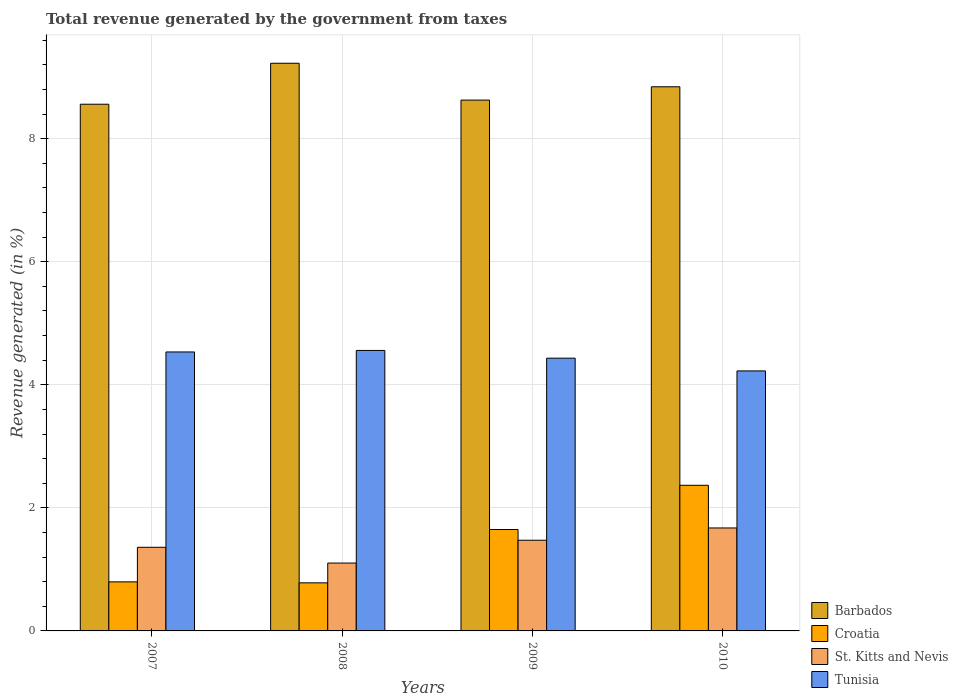How many different coloured bars are there?
Your response must be concise. 4. Are the number of bars per tick equal to the number of legend labels?
Keep it short and to the point. Yes. Are the number of bars on each tick of the X-axis equal?
Your answer should be very brief. Yes. How many bars are there on the 2nd tick from the left?
Offer a terse response. 4. What is the label of the 3rd group of bars from the left?
Offer a very short reply. 2009. In how many cases, is the number of bars for a given year not equal to the number of legend labels?
Offer a very short reply. 0. What is the total revenue generated in St. Kitts and Nevis in 2010?
Provide a short and direct response. 1.67. Across all years, what is the maximum total revenue generated in Croatia?
Your answer should be very brief. 2.37. Across all years, what is the minimum total revenue generated in Tunisia?
Offer a very short reply. 4.23. In which year was the total revenue generated in Barbados maximum?
Provide a short and direct response. 2008. In which year was the total revenue generated in St. Kitts and Nevis minimum?
Give a very brief answer. 2008. What is the total total revenue generated in Tunisia in the graph?
Offer a terse response. 17.75. What is the difference between the total revenue generated in Tunisia in 2007 and that in 2009?
Your answer should be compact. 0.1. What is the difference between the total revenue generated in Tunisia in 2007 and the total revenue generated in Barbados in 2010?
Offer a very short reply. -4.31. What is the average total revenue generated in St. Kitts and Nevis per year?
Offer a very short reply. 1.4. In the year 2009, what is the difference between the total revenue generated in Croatia and total revenue generated in Barbados?
Your answer should be very brief. -6.98. What is the ratio of the total revenue generated in Barbados in 2008 to that in 2010?
Your response must be concise. 1.04. Is the total revenue generated in St. Kitts and Nevis in 2007 less than that in 2010?
Provide a succinct answer. Yes. Is the difference between the total revenue generated in Croatia in 2007 and 2009 greater than the difference between the total revenue generated in Barbados in 2007 and 2009?
Your response must be concise. No. What is the difference between the highest and the second highest total revenue generated in Tunisia?
Your response must be concise. 0.02. What is the difference between the highest and the lowest total revenue generated in Tunisia?
Your answer should be compact. 0.33. In how many years, is the total revenue generated in Tunisia greater than the average total revenue generated in Tunisia taken over all years?
Offer a very short reply. 2. Is the sum of the total revenue generated in St. Kitts and Nevis in 2007 and 2008 greater than the maximum total revenue generated in Tunisia across all years?
Ensure brevity in your answer.  No. Is it the case that in every year, the sum of the total revenue generated in Croatia and total revenue generated in Barbados is greater than the sum of total revenue generated in Tunisia and total revenue generated in St. Kitts and Nevis?
Make the answer very short. No. What does the 3rd bar from the left in 2008 represents?
Keep it short and to the point. St. Kitts and Nevis. What does the 4th bar from the right in 2008 represents?
Keep it short and to the point. Barbados. Are all the bars in the graph horizontal?
Your answer should be compact. No. How many years are there in the graph?
Provide a succinct answer. 4. Does the graph contain any zero values?
Offer a terse response. No. Does the graph contain grids?
Your answer should be compact. Yes. How are the legend labels stacked?
Offer a terse response. Vertical. What is the title of the graph?
Provide a succinct answer. Total revenue generated by the government from taxes. What is the label or title of the Y-axis?
Keep it short and to the point. Revenue generated (in %). What is the Revenue generated (in %) of Barbados in 2007?
Offer a very short reply. 8.56. What is the Revenue generated (in %) in Croatia in 2007?
Ensure brevity in your answer.  0.8. What is the Revenue generated (in %) of St. Kitts and Nevis in 2007?
Keep it short and to the point. 1.36. What is the Revenue generated (in %) in Tunisia in 2007?
Your response must be concise. 4.53. What is the Revenue generated (in %) in Barbados in 2008?
Your answer should be compact. 9.23. What is the Revenue generated (in %) of Croatia in 2008?
Keep it short and to the point. 0.78. What is the Revenue generated (in %) of St. Kitts and Nevis in 2008?
Give a very brief answer. 1.1. What is the Revenue generated (in %) in Tunisia in 2008?
Make the answer very short. 4.56. What is the Revenue generated (in %) in Barbados in 2009?
Provide a short and direct response. 8.63. What is the Revenue generated (in %) of Croatia in 2009?
Make the answer very short. 1.65. What is the Revenue generated (in %) of St. Kitts and Nevis in 2009?
Make the answer very short. 1.47. What is the Revenue generated (in %) of Tunisia in 2009?
Give a very brief answer. 4.43. What is the Revenue generated (in %) of Barbados in 2010?
Provide a succinct answer. 8.84. What is the Revenue generated (in %) in Croatia in 2010?
Give a very brief answer. 2.37. What is the Revenue generated (in %) in St. Kitts and Nevis in 2010?
Keep it short and to the point. 1.67. What is the Revenue generated (in %) in Tunisia in 2010?
Offer a very short reply. 4.23. Across all years, what is the maximum Revenue generated (in %) in Barbados?
Make the answer very short. 9.23. Across all years, what is the maximum Revenue generated (in %) of Croatia?
Keep it short and to the point. 2.37. Across all years, what is the maximum Revenue generated (in %) of St. Kitts and Nevis?
Provide a succinct answer. 1.67. Across all years, what is the maximum Revenue generated (in %) of Tunisia?
Offer a very short reply. 4.56. Across all years, what is the minimum Revenue generated (in %) of Barbados?
Give a very brief answer. 8.56. Across all years, what is the minimum Revenue generated (in %) of Croatia?
Give a very brief answer. 0.78. Across all years, what is the minimum Revenue generated (in %) of St. Kitts and Nevis?
Make the answer very short. 1.1. Across all years, what is the minimum Revenue generated (in %) of Tunisia?
Offer a very short reply. 4.23. What is the total Revenue generated (in %) in Barbados in the graph?
Make the answer very short. 35.25. What is the total Revenue generated (in %) of Croatia in the graph?
Offer a very short reply. 5.59. What is the total Revenue generated (in %) of St. Kitts and Nevis in the graph?
Ensure brevity in your answer.  5.61. What is the total Revenue generated (in %) in Tunisia in the graph?
Your answer should be very brief. 17.75. What is the difference between the Revenue generated (in %) in Barbados in 2007 and that in 2008?
Provide a short and direct response. -0.67. What is the difference between the Revenue generated (in %) of Croatia in 2007 and that in 2008?
Ensure brevity in your answer.  0.02. What is the difference between the Revenue generated (in %) in St. Kitts and Nevis in 2007 and that in 2008?
Provide a short and direct response. 0.26. What is the difference between the Revenue generated (in %) in Tunisia in 2007 and that in 2008?
Your answer should be compact. -0.02. What is the difference between the Revenue generated (in %) in Barbados in 2007 and that in 2009?
Provide a succinct answer. -0.07. What is the difference between the Revenue generated (in %) of Croatia in 2007 and that in 2009?
Offer a very short reply. -0.85. What is the difference between the Revenue generated (in %) in St. Kitts and Nevis in 2007 and that in 2009?
Make the answer very short. -0.11. What is the difference between the Revenue generated (in %) of Tunisia in 2007 and that in 2009?
Your response must be concise. 0.1. What is the difference between the Revenue generated (in %) in Barbados in 2007 and that in 2010?
Ensure brevity in your answer.  -0.28. What is the difference between the Revenue generated (in %) of Croatia in 2007 and that in 2010?
Your response must be concise. -1.57. What is the difference between the Revenue generated (in %) of St. Kitts and Nevis in 2007 and that in 2010?
Your answer should be very brief. -0.31. What is the difference between the Revenue generated (in %) of Tunisia in 2007 and that in 2010?
Make the answer very short. 0.31. What is the difference between the Revenue generated (in %) of Barbados in 2008 and that in 2009?
Your answer should be very brief. 0.6. What is the difference between the Revenue generated (in %) of Croatia in 2008 and that in 2009?
Offer a terse response. -0.87. What is the difference between the Revenue generated (in %) in St. Kitts and Nevis in 2008 and that in 2009?
Your answer should be compact. -0.37. What is the difference between the Revenue generated (in %) in Tunisia in 2008 and that in 2009?
Ensure brevity in your answer.  0.13. What is the difference between the Revenue generated (in %) in Barbados in 2008 and that in 2010?
Provide a succinct answer. 0.38. What is the difference between the Revenue generated (in %) in Croatia in 2008 and that in 2010?
Keep it short and to the point. -1.59. What is the difference between the Revenue generated (in %) of St. Kitts and Nevis in 2008 and that in 2010?
Your response must be concise. -0.57. What is the difference between the Revenue generated (in %) in Tunisia in 2008 and that in 2010?
Give a very brief answer. 0.33. What is the difference between the Revenue generated (in %) of Barbados in 2009 and that in 2010?
Ensure brevity in your answer.  -0.22. What is the difference between the Revenue generated (in %) of Croatia in 2009 and that in 2010?
Your response must be concise. -0.72. What is the difference between the Revenue generated (in %) in St. Kitts and Nevis in 2009 and that in 2010?
Ensure brevity in your answer.  -0.2. What is the difference between the Revenue generated (in %) in Tunisia in 2009 and that in 2010?
Your answer should be compact. 0.21. What is the difference between the Revenue generated (in %) in Barbados in 2007 and the Revenue generated (in %) in Croatia in 2008?
Your answer should be compact. 7.78. What is the difference between the Revenue generated (in %) in Barbados in 2007 and the Revenue generated (in %) in St. Kitts and Nevis in 2008?
Your response must be concise. 7.46. What is the difference between the Revenue generated (in %) of Barbados in 2007 and the Revenue generated (in %) of Tunisia in 2008?
Ensure brevity in your answer.  4. What is the difference between the Revenue generated (in %) of Croatia in 2007 and the Revenue generated (in %) of St. Kitts and Nevis in 2008?
Give a very brief answer. -0.31. What is the difference between the Revenue generated (in %) of Croatia in 2007 and the Revenue generated (in %) of Tunisia in 2008?
Keep it short and to the point. -3.76. What is the difference between the Revenue generated (in %) in St. Kitts and Nevis in 2007 and the Revenue generated (in %) in Tunisia in 2008?
Ensure brevity in your answer.  -3.2. What is the difference between the Revenue generated (in %) of Barbados in 2007 and the Revenue generated (in %) of Croatia in 2009?
Your answer should be compact. 6.91. What is the difference between the Revenue generated (in %) of Barbados in 2007 and the Revenue generated (in %) of St. Kitts and Nevis in 2009?
Ensure brevity in your answer.  7.09. What is the difference between the Revenue generated (in %) of Barbados in 2007 and the Revenue generated (in %) of Tunisia in 2009?
Ensure brevity in your answer.  4.13. What is the difference between the Revenue generated (in %) in Croatia in 2007 and the Revenue generated (in %) in St. Kitts and Nevis in 2009?
Provide a succinct answer. -0.68. What is the difference between the Revenue generated (in %) of Croatia in 2007 and the Revenue generated (in %) of Tunisia in 2009?
Give a very brief answer. -3.64. What is the difference between the Revenue generated (in %) in St. Kitts and Nevis in 2007 and the Revenue generated (in %) in Tunisia in 2009?
Offer a very short reply. -3.07. What is the difference between the Revenue generated (in %) of Barbados in 2007 and the Revenue generated (in %) of Croatia in 2010?
Provide a succinct answer. 6.19. What is the difference between the Revenue generated (in %) of Barbados in 2007 and the Revenue generated (in %) of St. Kitts and Nevis in 2010?
Your answer should be compact. 6.89. What is the difference between the Revenue generated (in %) in Barbados in 2007 and the Revenue generated (in %) in Tunisia in 2010?
Your answer should be compact. 4.33. What is the difference between the Revenue generated (in %) in Croatia in 2007 and the Revenue generated (in %) in St. Kitts and Nevis in 2010?
Provide a short and direct response. -0.88. What is the difference between the Revenue generated (in %) of Croatia in 2007 and the Revenue generated (in %) of Tunisia in 2010?
Offer a very short reply. -3.43. What is the difference between the Revenue generated (in %) in St. Kitts and Nevis in 2007 and the Revenue generated (in %) in Tunisia in 2010?
Give a very brief answer. -2.87. What is the difference between the Revenue generated (in %) of Barbados in 2008 and the Revenue generated (in %) of Croatia in 2009?
Make the answer very short. 7.58. What is the difference between the Revenue generated (in %) in Barbados in 2008 and the Revenue generated (in %) in St. Kitts and Nevis in 2009?
Offer a very short reply. 7.75. What is the difference between the Revenue generated (in %) in Barbados in 2008 and the Revenue generated (in %) in Tunisia in 2009?
Provide a succinct answer. 4.79. What is the difference between the Revenue generated (in %) in Croatia in 2008 and the Revenue generated (in %) in St. Kitts and Nevis in 2009?
Your answer should be very brief. -0.69. What is the difference between the Revenue generated (in %) of Croatia in 2008 and the Revenue generated (in %) of Tunisia in 2009?
Offer a terse response. -3.65. What is the difference between the Revenue generated (in %) of St. Kitts and Nevis in 2008 and the Revenue generated (in %) of Tunisia in 2009?
Ensure brevity in your answer.  -3.33. What is the difference between the Revenue generated (in %) of Barbados in 2008 and the Revenue generated (in %) of Croatia in 2010?
Ensure brevity in your answer.  6.86. What is the difference between the Revenue generated (in %) of Barbados in 2008 and the Revenue generated (in %) of St. Kitts and Nevis in 2010?
Your response must be concise. 7.55. What is the difference between the Revenue generated (in %) of Barbados in 2008 and the Revenue generated (in %) of Tunisia in 2010?
Provide a short and direct response. 5. What is the difference between the Revenue generated (in %) of Croatia in 2008 and the Revenue generated (in %) of St. Kitts and Nevis in 2010?
Ensure brevity in your answer.  -0.89. What is the difference between the Revenue generated (in %) in Croatia in 2008 and the Revenue generated (in %) in Tunisia in 2010?
Provide a short and direct response. -3.44. What is the difference between the Revenue generated (in %) in St. Kitts and Nevis in 2008 and the Revenue generated (in %) in Tunisia in 2010?
Your response must be concise. -3.12. What is the difference between the Revenue generated (in %) in Barbados in 2009 and the Revenue generated (in %) in Croatia in 2010?
Offer a terse response. 6.26. What is the difference between the Revenue generated (in %) of Barbados in 2009 and the Revenue generated (in %) of St. Kitts and Nevis in 2010?
Give a very brief answer. 6.95. What is the difference between the Revenue generated (in %) in Barbados in 2009 and the Revenue generated (in %) in Tunisia in 2010?
Offer a terse response. 4.4. What is the difference between the Revenue generated (in %) in Croatia in 2009 and the Revenue generated (in %) in St. Kitts and Nevis in 2010?
Offer a terse response. -0.03. What is the difference between the Revenue generated (in %) in Croatia in 2009 and the Revenue generated (in %) in Tunisia in 2010?
Offer a terse response. -2.58. What is the difference between the Revenue generated (in %) of St. Kitts and Nevis in 2009 and the Revenue generated (in %) of Tunisia in 2010?
Offer a very short reply. -2.75. What is the average Revenue generated (in %) of Barbados per year?
Provide a short and direct response. 8.81. What is the average Revenue generated (in %) in Croatia per year?
Keep it short and to the point. 1.4. What is the average Revenue generated (in %) in St. Kitts and Nevis per year?
Your answer should be very brief. 1.4. What is the average Revenue generated (in %) of Tunisia per year?
Offer a very short reply. 4.44. In the year 2007, what is the difference between the Revenue generated (in %) in Barbados and Revenue generated (in %) in Croatia?
Your answer should be compact. 7.76. In the year 2007, what is the difference between the Revenue generated (in %) of Barbados and Revenue generated (in %) of St. Kitts and Nevis?
Your response must be concise. 7.2. In the year 2007, what is the difference between the Revenue generated (in %) in Barbados and Revenue generated (in %) in Tunisia?
Your answer should be very brief. 4.03. In the year 2007, what is the difference between the Revenue generated (in %) in Croatia and Revenue generated (in %) in St. Kitts and Nevis?
Offer a very short reply. -0.56. In the year 2007, what is the difference between the Revenue generated (in %) in Croatia and Revenue generated (in %) in Tunisia?
Keep it short and to the point. -3.74. In the year 2007, what is the difference between the Revenue generated (in %) in St. Kitts and Nevis and Revenue generated (in %) in Tunisia?
Keep it short and to the point. -3.17. In the year 2008, what is the difference between the Revenue generated (in %) in Barbados and Revenue generated (in %) in Croatia?
Offer a terse response. 8.44. In the year 2008, what is the difference between the Revenue generated (in %) of Barbados and Revenue generated (in %) of St. Kitts and Nevis?
Offer a terse response. 8.12. In the year 2008, what is the difference between the Revenue generated (in %) in Barbados and Revenue generated (in %) in Tunisia?
Ensure brevity in your answer.  4.67. In the year 2008, what is the difference between the Revenue generated (in %) in Croatia and Revenue generated (in %) in St. Kitts and Nevis?
Your answer should be compact. -0.32. In the year 2008, what is the difference between the Revenue generated (in %) of Croatia and Revenue generated (in %) of Tunisia?
Provide a succinct answer. -3.78. In the year 2008, what is the difference between the Revenue generated (in %) in St. Kitts and Nevis and Revenue generated (in %) in Tunisia?
Your response must be concise. -3.46. In the year 2009, what is the difference between the Revenue generated (in %) in Barbados and Revenue generated (in %) in Croatia?
Offer a very short reply. 6.98. In the year 2009, what is the difference between the Revenue generated (in %) of Barbados and Revenue generated (in %) of St. Kitts and Nevis?
Offer a terse response. 7.15. In the year 2009, what is the difference between the Revenue generated (in %) of Barbados and Revenue generated (in %) of Tunisia?
Offer a terse response. 4.19. In the year 2009, what is the difference between the Revenue generated (in %) in Croatia and Revenue generated (in %) in St. Kitts and Nevis?
Your response must be concise. 0.17. In the year 2009, what is the difference between the Revenue generated (in %) in Croatia and Revenue generated (in %) in Tunisia?
Make the answer very short. -2.78. In the year 2009, what is the difference between the Revenue generated (in %) in St. Kitts and Nevis and Revenue generated (in %) in Tunisia?
Give a very brief answer. -2.96. In the year 2010, what is the difference between the Revenue generated (in %) of Barbados and Revenue generated (in %) of Croatia?
Provide a short and direct response. 6.48. In the year 2010, what is the difference between the Revenue generated (in %) in Barbados and Revenue generated (in %) in St. Kitts and Nevis?
Ensure brevity in your answer.  7.17. In the year 2010, what is the difference between the Revenue generated (in %) of Barbados and Revenue generated (in %) of Tunisia?
Offer a terse response. 4.62. In the year 2010, what is the difference between the Revenue generated (in %) of Croatia and Revenue generated (in %) of St. Kitts and Nevis?
Provide a succinct answer. 0.69. In the year 2010, what is the difference between the Revenue generated (in %) of Croatia and Revenue generated (in %) of Tunisia?
Your response must be concise. -1.86. In the year 2010, what is the difference between the Revenue generated (in %) of St. Kitts and Nevis and Revenue generated (in %) of Tunisia?
Offer a very short reply. -2.55. What is the ratio of the Revenue generated (in %) in Barbados in 2007 to that in 2008?
Offer a very short reply. 0.93. What is the ratio of the Revenue generated (in %) in Croatia in 2007 to that in 2008?
Keep it short and to the point. 1.02. What is the ratio of the Revenue generated (in %) in St. Kitts and Nevis in 2007 to that in 2008?
Your response must be concise. 1.23. What is the ratio of the Revenue generated (in %) of Tunisia in 2007 to that in 2008?
Keep it short and to the point. 0.99. What is the ratio of the Revenue generated (in %) of Croatia in 2007 to that in 2009?
Keep it short and to the point. 0.48. What is the ratio of the Revenue generated (in %) in St. Kitts and Nevis in 2007 to that in 2009?
Offer a terse response. 0.92. What is the ratio of the Revenue generated (in %) of Tunisia in 2007 to that in 2009?
Your answer should be very brief. 1.02. What is the ratio of the Revenue generated (in %) in Barbados in 2007 to that in 2010?
Make the answer very short. 0.97. What is the ratio of the Revenue generated (in %) in Croatia in 2007 to that in 2010?
Your answer should be very brief. 0.34. What is the ratio of the Revenue generated (in %) of St. Kitts and Nevis in 2007 to that in 2010?
Your answer should be very brief. 0.81. What is the ratio of the Revenue generated (in %) of Tunisia in 2007 to that in 2010?
Give a very brief answer. 1.07. What is the ratio of the Revenue generated (in %) of Barbados in 2008 to that in 2009?
Your answer should be compact. 1.07. What is the ratio of the Revenue generated (in %) of Croatia in 2008 to that in 2009?
Your response must be concise. 0.47. What is the ratio of the Revenue generated (in %) in St. Kitts and Nevis in 2008 to that in 2009?
Keep it short and to the point. 0.75. What is the ratio of the Revenue generated (in %) in Tunisia in 2008 to that in 2009?
Your answer should be compact. 1.03. What is the ratio of the Revenue generated (in %) of Barbados in 2008 to that in 2010?
Your answer should be very brief. 1.04. What is the ratio of the Revenue generated (in %) in Croatia in 2008 to that in 2010?
Your answer should be compact. 0.33. What is the ratio of the Revenue generated (in %) of St. Kitts and Nevis in 2008 to that in 2010?
Ensure brevity in your answer.  0.66. What is the ratio of the Revenue generated (in %) in Tunisia in 2008 to that in 2010?
Provide a short and direct response. 1.08. What is the ratio of the Revenue generated (in %) of Barbados in 2009 to that in 2010?
Your answer should be very brief. 0.98. What is the ratio of the Revenue generated (in %) of Croatia in 2009 to that in 2010?
Provide a succinct answer. 0.7. What is the ratio of the Revenue generated (in %) in St. Kitts and Nevis in 2009 to that in 2010?
Your answer should be compact. 0.88. What is the ratio of the Revenue generated (in %) of Tunisia in 2009 to that in 2010?
Your response must be concise. 1.05. What is the difference between the highest and the second highest Revenue generated (in %) in Barbados?
Offer a terse response. 0.38. What is the difference between the highest and the second highest Revenue generated (in %) of Croatia?
Offer a terse response. 0.72. What is the difference between the highest and the second highest Revenue generated (in %) of St. Kitts and Nevis?
Your answer should be very brief. 0.2. What is the difference between the highest and the second highest Revenue generated (in %) of Tunisia?
Provide a succinct answer. 0.02. What is the difference between the highest and the lowest Revenue generated (in %) in Barbados?
Your response must be concise. 0.67. What is the difference between the highest and the lowest Revenue generated (in %) of Croatia?
Give a very brief answer. 1.59. What is the difference between the highest and the lowest Revenue generated (in %) of St. Kitts and Nevis?
Offer a terse response. 0.57. What is the difference between the highest and the lowest Revenue generated (in %) of Tunisia?
Offer a terse response. 0.33. 